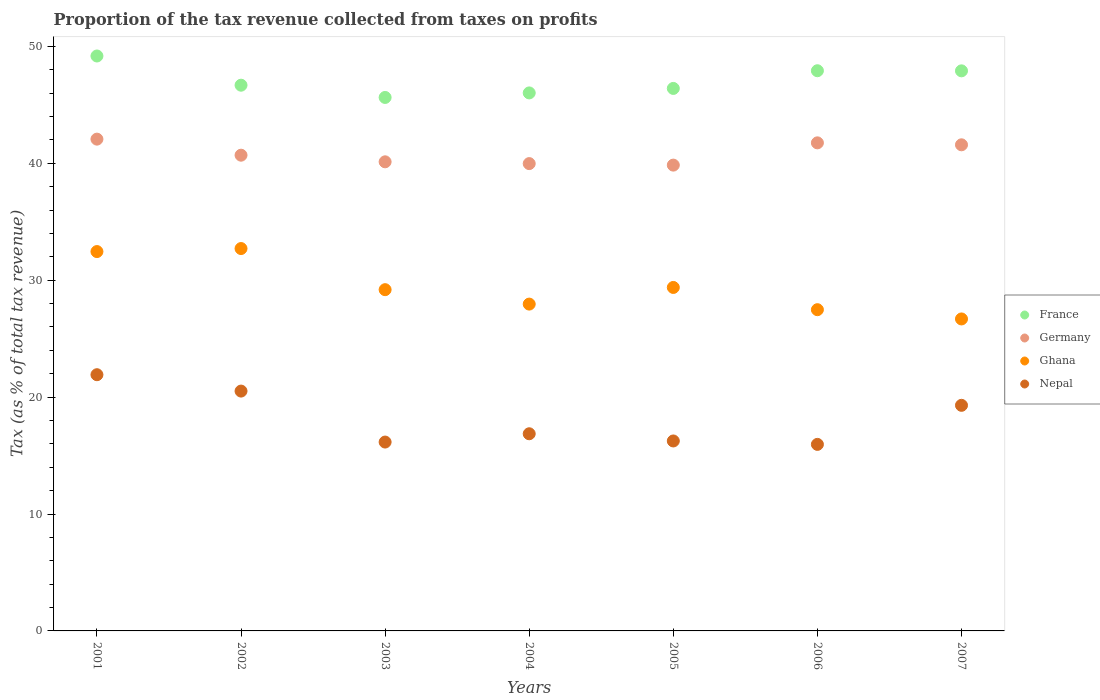What is the proportion of the tax revenue collected in Germany in 2002?
Your response must be concise. 40.69. Across all years, what is the maximum proportion of the tax revenue collected in Ghana?
Provide a succinct answer. 32.7. Across all years, what is the minimum proportion of the tax revenue collected in France?
Make the answer very short. 45.63. In which year was the proportion of the tax revenue collected in Germany minimum?
Provide a succinct answer. 2005. What is the total proportion of the tax revenue collected in Ghana in the graph?
Your answer should be very brief. 205.83. What is the difference between the proportion of the tax revenue collected in France in 2002 and that in 2007?
Your answer should be very brief. -1.23. What is the difference between the proportion of the tax revenue collected in Nepal in 2004 and the proportion of the tax revenue collected in France in 2002?
Give a very brief answer. -29.81. What is the average proportion of the tax revenue collected in Nepal per year?
Provide a short and direct response. 18.13. In the year 2002, what is the difference between the proportion of the tax revenue collected in Germany and proportion of the tax revenue collected in Ghana?
Provide a short and direct response. 7.99. What is the ratio of the proportion of the tax revenue collected in Germany in 2001 to that in 2002?
Make the answer very short. 1.03. Is the proportion of the tax revenue collected in France in 2002 less than that in 2006?
Make the answer very short. Yes. What is the difference between the highest and the second highest proportion of the tax revenue collected in Germany?
Provide a succinct answer. 0.32. What is the difference between the highest and the lowest proportion of the tax revenue collected in Nepal?
Provide a succinct answer. 5.96. In how many years, is the proportion of the tax revenue collected in Nepal greater than the average proportion of the tax revenue collected in Nepal taken over all years?
Provide a short and direct response. 3. Is the sum of the proportion of the tax revenue collected in Germany in 2003 and 2004 greater than the maximum proportion of the tax revenue collected in Ghana across all years?
Provide a succinct answer. Yes. Is it the case that in every year, the sum of the proportion of the tax revenue collected in France and proportion of the tax revenue collected in Nepal  is greater than the sum of proportion of the tax revenue collected in Germany and proportion of the tax revenue collected in Ghana?
Your answer should be very brief. Yes. How many dotlines are there?
Provide a succinct answer. 4. What is the difference between two consecutive major ticks on the Y-axis?
Your answer should be very brief. 10. Are the values on the major ticks of Y-axis written in scientific E-notation?
Make the answer very short. No. Does the graph contain grids?
Your response must be concise. No. How many legend labels are there?
Keep it short and to the point. 4. How are the legend labels stacked?
Provide a short and direct response. Vertical. What is the title of the graph?
Offer a very short reply. Proportion of the tax revenue collected from taxes on profits. Does "Indonesia" appear as one of the legend labels in the graph?
Your answer should be compact. No. What is the label or title of the X-axis?
Provide a short and direct response. Years. What is the label or title of the Y-axis?
Your answer should be compact. Tax (as % of total tax revenue). What is the Tax (as % of total tax revenue) in France in 2001?
Offer a very short reply. 49.17. What is the Tax (as % of total tax revenue) in Germany in 2001?
Offer a very short reply. 42.06. What is the Tax (as % of total tax revenue) in Ghana in 2001?
Provide a succinct answer. 32.45. What is the Tax (as % of total tax revenue) of Nepal in 2001?
Give a very brief answer. 21.91. What is the Tax (as % of total tax revenue) of France in 2002?
Keep it short and to the point. 46.68. What is the Tax (as % of total tax revenue) in Germany in 2002?
Offer a terse response. 40.69. What is the Tax (as % of total tax revenue) of Ghana in 2002?
Offer a terse response. 32.7. What is the Tax (as % of total tax revenue) in Nepal in 2002?
Ensure brevity in your answer.  20.51. What is the Tax (as % of total tax revenue) of France in 2003?
Your response must be concise. 45.63. What is the Tax (as % of total tax revenue) in Germany in 2003?
Ensure brevity in your answer.  40.12. What is the Tax (as % of total tax revenue) in Ghana in 2003?
Ensure brevity in your answer.  29.19. What is the Tax (as % of total tax revenue) in Nepal in 2003?
Keep it short and to the point. 16.15. What is the Tax (as % of total tax revenue) in France in 2004?
Offer a terse response. 46.02. What is the Tax (as % of total tax revenue) in Germany in 2004?
Keep it short and to the point. 39.97. What is the Tax (as % of total tax revenue) of Ghana in 2004?
Provide a succinct answer. 27.95. What is the Tax (as % of total tax revenue) of Nepal in 2004?
Provide a succinct answer. 16.86. What is the Tax (as % of total tax revenue) of France in 2005?
Make the answer very short. 46.4. What is the Tax (as % of total tax revenue) in Germany in 2005?
Offer a terse response. 39.84. What is the Tax (as % of total tax revenue) of Ghana in 2005?
Your answer should be compact. 29.38. What is the Tax (as % of total tax revenue) of Nepal in 2005?
Provide a short and direct response. 16.25. What is the Tax (as % of total tax revenue) of France in 2006?
Your response must be concise. 47.91. What is the Tax (as % of total tax revenue) of Germany in 2006?
Give a very brief answer. 41.74. What is the Tax (as % of total tax revenue) of Ghana in 2006?
Your answer should be very brief. 27.47. What is the Tax (as % of total tax revenue) of Nepal in 2006?
Make the answer very short. 15.95. What is the Tax (as % of total tax revenue) of France in 2007?
Give a very brief answer. 47.9. What is the Tax (as % of total tax revenue) in Germany in 2007?
Your answer should be compact. 41.58. What is the Tax (as % of total tax revenue) in Ghana in 2007?
Offer a very short reply. 26.68. What is the Tax (as % of total tax revenue) of Nepal in 2007?
Give a very brief answer. 19.3. Across all years, what is the maximum Tax (as % of total tax revenue) of France?
Offer a very short reply. 49.17. Across all years, what is the maximum Tax (as % of total tax revenue) of Germany?
Offer a terse response. 42.06. Across all years, what is the maximum Tax (as % of total tax revenue) of Ghana?
Provide a succinct answer. 32.7. Across all years, what is the maximum Tax (as % of total tax revenue) in Nepal?
Offer a very short reply. 21.91. Across all years, what is the minimum Tax (as % of total tax revenue) in France?
Offer a very short reply. 45.63. Across all years, what is the minimum Tax (as % of total tax revenue) of Germany?
Offer a very short reply. 39.84. Across all years, what is the minimum Tax (as % of total tax revenue) in Ghana?
Give a very brief answer. 26.68. Across all years, what is the minimum Tax (as % of total tax revenue) of Nepal?
Your answer should be very brief. 15.95. What is the total Tax (as % of total tax revenue) in France in the graph?
Provide a short and direct response. 329.71. What is the total Tax (as % of total tax revenue) of Germany in the graph?
Make the answer very short. 286.01. What is the total Tax (as % of total tax revenue) of Ghana in the graph?
Keep it short and to the point. 205.83. What is the total Tax (as % of total tax revenue) of Nepal in the graph?
Offer a very short reply. 126.94. What is the difference between the Tax (as % of total tax revenue) of France in 2001 and that in 2002?
Provide a short and direct response. 2.5. What is the difference between the Tax (as % of total tax revenue) of Germany in 2001 and that in 2002?
Ensure brevity in your answer.  1.37. What is the difference between the Tax (as % of total tax revenue) in Ghana in 2001 and that in 2002?
Keep it short and to the point. -0.26. What is the difference between the Tax (as % of total tax revenue) in Nepal in 2001 and that in 2002?
Offer a terse response. 1.4. What is the difference between the Tax (as % of total tax revenue) in France in 2001 and that in 2003?
Keep it short and to the point. 3.55. What is the difference between the Tax (as % of total tax revenue) of Germany in 2001 and that in 2003?
Your answer should be very brief. 1.94. What is the difference between the Tax (as % of total tax revenue) in Ghana in 2001 and that in 2003?
Provide a succinct answer. 3.26. What is the difference between the Tax (as % of total tax revenue) of Nepal in 2001 and that in 2003?
Offer a terse response. 5.76. What is the difference between the Tax (as % of total tax revenue) in France in 2001 and that in 2004?
Keep it short and to the point. 3.16. What is the difference between the Tax (as % of total tax revenue) of Germany in 2001 and that in 2004?
Your response must be concise. 2.09. What is the difference between the Tax (as % of total tax revenue) of Ghana in 2001 and that in 2004?
Keep it short and to the point. 4.49. What is the difference between the Tax (as % of total tax revenue) of Nepal in 2001 and that in 2004?
Give a very brief answer. 5.05. What is the difference between the Tax (as % of total tax revenue) of France in 2001 and that in 2005?
Provide a short and direct response. 2.77. What is the difference between the Tax (as % of total tax revenue) in Germany in 2001 and that in 2005?
Offer a terse response. 2.22. What is the difference between the Tax (as % of total tax revenue) of Ghana in 2001 and that in 2005?
Provide a short and direct response. 3.07. What is the difference between the Tax (as % of total tax revenue) in Nepal in 2001 and that in 2005?
Make the answer very short. 5.67. What is the difference between the Tax (as % of total tax revenue) in France in 2001 and that in 2006?
Make the answer very short. 1.26. What is the difference between the Tax (as % of total tax revenue) in Germany in 2001 and that in 2006?
Make the answer very short. 0.32. What is the difference between the Tax (as % of total tax revenue) in Ghana in 2001 and that in 2006?
Offer a terse response. 4.97. What is the difference between the Tax (as % of total tax revenue) in Nepal in 2001 and that in 2006?
Give a very brief answer. 5.96. What is the difference between the Tax (as % of total tax revenue) of France in 2001 and that in 2007?
Your answer should be compact. 1.27. What is the difference between the Tax (as % of total tax revenue) of Germany in 2001 and that in 2007?
Provide a succinct answer. 0.49. What is the difference between the Tax (as % of total tax revenue) of Ghana in 2001 and that in 2007?
Ensure brevity in your answer.  5.76. What is the difference between the Tax (as % of total tax revenue) in Nepal in 2001 and that in 2007?
Provide a succinct answer. 2.62. What is the difference between the Tax (as % of total tax revenue) in France in 2002 and that in 2003?
Provide a short and direct response. 1.05. What is the difference between the Tax (as % of total tax revenue) of Germany in 2002 and that in 2003?
Make the answer very short. 0.57. What is the difference between the Tax (as % of total tax revenue) in Ghana in 2002 and that in 2003?
Provide a succinct answer. 3.52. What is the difference between the Tax (as % of total tax revenue) of Nepal in 2002 and that in 2003?
Your answer should be very brief. 4.36. What is the difference between the Tax (as % of total tax revenue) of France in 2002 and that in 2004?
Offer a very short reply. 0.66. What is the difference between the Tax (as % of total tax revenue) in Germany in 2002 and that in 2004?
Provide a short and direct response. 0.72. What is the difference between the Tax (as % of total tax revenue) in Ghana in 2002 and that in 2004?
Keep it short and to the point. 4.75. What is the difference between the Tax (as % of total tax revenue) of Nepal in 2002 and that in 2004?
Offer a terse response. 3.65. What is the difference between the Tax (as % of total tax revenue) in France in 2002 and that in 2005?
Provide a short and direct response. 0.28. What is the difference between the Tax (as % of total tax revenue) in Germany in 2002 and that in 2005?
Give a very brief answer. 0.85. What is the difference between the Tax (as % of total tax revenue) of Ghana in 2002 and that in 2005?
Provide a succinct answer. 3.33. What is the difference between the Tax (as % of total tax revenue) in Nepal in 2002 and that in 2005?
Keep it short and to the point. 4.27. What is the difference between the Tax (as % of total tax revenue) in France in 2002 and that in 2006?
Provide a short and direct response. -1.24. What is the difference between the Tax (as % of total tax revenue) in Germany in 2002 and that in 2006?
Offer a very short reply. -1.06. What is the difference between the Tax (as % of total tax revenue) of Ghana in 2002 and that in 2006?
Offer a terse response. 5.23. What is the difference between the Tax (as % of total tax revenue) of Nepal in 2002 and that in 2006?
Give a very brief answer. 4.56. What is the difference between the Tax (as % of total tax revenue) in France in 2002 and that in 2007?
Keep it short and to the point. -1.23. What is the difference between the Tax (as % of total tax revenue) in Germany in 2002 and that in 2007?
Your answer should be very brief. -0.89. What is the difference between the Tax (as % of total tax revenue) in Ghana in 2002 and that in 2007?
Your answer should be compact. 6.02. What is the difference between the Tax (as % of total tax revenue) of Nepal in 2002 and that in 2007?
Provide a short and direct response. 1.22. What is the difference between the Tax (as % of total tax revenue) of France in 2003 and that in 2004?
Give a very brief answer. -0.39. What is the difference between the Tax (as % of total tax revenue) of Germany in 2003 and that in 2004?
Offer a very short reply. 0.15. What is the difference between the Tax (as % of total tax revenue) in Ghana in 2003 and that in 2004?
Your answer should be very brief. 1.23. What is the difference between the Tax (as % of total tax revenue) in Nepal in 2003 and that in 2004?
Give a very brief answer. -0.71. What is the difference between the Tax (as % of total tax revenue) in France in 2003 and that in 2005?
Offer a very short reply. -0.77. What is the difference between the Tax (as % of total tax revenue) of Germany in 2003 and that in 2005?
Ensure brevity in your answer.  0.28. What is the difference between the Tax (as % of total tax revenue) of Ghana in 2003 and that in 2005?
Keep it short and to the point. -0.19. What is the difference between the Tax (as % of total tax revenue) of Nepal in 2003 and that in 2005?
Ensure brevity in your answer.  -0.09. What is the difference between the Tax (as % of total tax revenue) of France in 2003 and that in 2006?
Your response must be concise. -2.29. What is the difference between the Tax (as % of total tax revenue) of Germany in 2003 and that in 2006?
Your answer should be compact. -1.62. What is the difference between the Tax (as % of total tax revenue) of Ghana in 2003 and that in 2006?
Your response must be concise. 1.71. What is the difference between the Tax (as % of total tax revenue) of Nepal in 2003 and that in 2006?
Provide a short and direct response. 0.2. What is the difference between the Tax (as % of total tax revenue) of France in 2003 and that in 2007?
Your answer should be compact. -2.28. What is the difference between the Tax (as % of total tax revenue) in Germany in 2003 and that in 2007?
Your answer should be very brief. -1.45. What is the difference between the Tax (as % of total tax revenue) of Ghana in 2003 and that in 2007?
Ensure brevity in your answer.  2.5. What is the difference between the Tax (as % of total tax revenue) of Nepal in 2003 and that in 2007?
Your answer should be compact. -3.14. What is the difference between the Tax (as % of total tax revenue) in France in 2004 and that in 2005?
Ensure brevity in your answer.  -0.38. What is the difference between the Tax (as % of total tax revenue) of Germany in 2004 and that in 2005?
Provide a short and direct response. 0.13. What is the difference between the Tax (as % of total tax revenue) of Ghana in 2004 and that in 2005?
Make the answer very short. -1.42. What is the difference between the Tax (as % of total tax revenue) in Nepal in 2004 and that in 2005?
Your answer should be compact. 0.62. What is the difference between the Tax (as % of total tax revenue) in France in 2004 and that in 2006?
Make the answer very short. -1.9. What is the difference between the Tax (as % of total tax revenue) of Germany in 2004 and that in 2006?
Provide a succinct answer. -1.77. What is the difference between the Tax (as % of total tax revenue) of Ghana in 2004 and that in 2006?
Provide a succinct answer. 0.48. What is the difference between the Tax (as % of total tax revenue) in Nepal in 2004 and that in 2006?
Provide a short and direct response. 0.91. What is the difference between the Tax (as % of total tax revenue) of France in 2004 and that in 2007?
Give a very brief answer. -1.89. What is the difference between the Tax (as % of total tax revenue) of Germany in 2004 and that in 2007?
Your answer should be very brief. -1.61. What is the difference between the Tax (as % of total tax revenue) of Ghana in 2004 and that in 2007?
Offer a terse response. 1.27. What is the difference between the Tax (as % of total tax revenue) of Nepal in 2004 and that in 2007?
Your answer should be compact. -2.43. What is the difference between the Tax (as % of total tax revenue) in France in 2005 and that in 2006?
Your response must be concise. -1.51. What is the difference between the Tax (as % of total tax revenue) of Germany in 2005 and that in 2006?
Offer a terse response. -1.9. What is the difference between the Tax (as % of total tax revenue) in Ghana in 2005 and that in 2006?
Offer a very short reply. 1.9. What is the difference between the Tax (as % of total tax revenue) in Nepal in 2005 and that in 2006?
Offer a terse response. 0.29. What is the difference between the Tax (as % of total tax revenue) in France in 2005 and that in 2007?
Your answer should be compact. -1.5. What is the difference between the Tax (as % of total tax revenue) of Germany in 2005 and that in 2007?
Offer a very short reply. -1.74. What is the difference between the Tax (as % of total tax revenue) in Ghana in 2005 and that in 2007?
Provide a short and direct response. 2.69. What is the difference between the Tax (as % of total tax revenue) in Nepal in 2005 and that in 2007?
Give a very brief answer. -3.05. What is the difference between the Tax (as % of total tax revenue) in France in 2006 and that in 2007?
Make the answer very short. 0.01. What is the difference between the Tax (as % of total tax revenue) in Germany in 2006 and that in 2007?
Give a very brief answer. 0.17. What is the difference between the Tax (as % of total tax revenue) of Ghana in 2006 and that in 2007?
Give a very brief answer. 0.79. What is the difference between the Tax (as % of total tax revenue) of Nepal in 2006 and that in 2007?
Your response must be concise. -3.34. What is the difference between the Tax (as % of total tax revenue) in France in 2001 and the Tax (as % of total tax revenue) in Germany in 2002?
Your answer should be very brief. 8.48. What is the difference between the Tax (as % of total tax revenue) of France in 2001 and the Tax (as % of total tax revenue) of Ghana in 2002?
Offer a very short reply. 16.47. What is the difference between the Tax (as % of total tax revenue) of France in 2001 and the Tax (as % of total tax revenue) of Nepal in 2002?
Your answer should be compact. 28.66. What is the difference between the Tax (as % of total tax revenue) in Germany in 2001 and the Tax (as % of total tax revenue) in Ghana in 2002?
Make the answer very short. 9.36. What is the difference between the Tax (as % of total tax revenue) in Germany in 2001 and the Tax (as % of total tax revenue) in Nepal in 2002?
Provide a succinct answer. 21.55. What is the difference between the Tax (as % of total tax revenue) of Ghana in 2001 and the Tax (as % of total tax revenue) of Nepal in 2002?
Provide a short and direct response. 11.93. What is the difference between the Tax (as % of total tax revenue) of France in 2001 and the Tax (as % of total tax revenue) of Germany in 2003?
Keep it short and to the point. 9.05. What is the difference between the Tax (as % of total tax revenue) of France in 2001 and the Tax (as % of total tax revenue) of Ghana in 2003?
Make the answer very short. 19.99. What is the difference between the Tax (as % of total tax revenue) in France in 2001 and the Tax (as % of total tax revenue) in Nepal in 2003?
Give a very brief answer. 33.02. What is the difference between the Tax (as % of total tax revenue) of Germany in 2001 and the Tax (as % of total tax revenue) of Ghana in 2003?
Provide a short and direct response. 12.88. What is the difference between the Tax (as % of total tax revenue) of Germany in 2001 and the Tax (as % of total tax revenue) of Nepal in 2003?
Your answer should be compact. 25.91. What is the difference between the Tax (as % of total tax revenue) of Ghana in 2001 and the Tax (as % of total tax revenue) of Nepal in 2003?
Your answer should be compact. 16.29. What is the difference between the Tax (as % of total tax revenue) in France in 2001 and the Tax (as % of total tax revenue) in Germany in 2004?
Keep it short and to the point. 9.2. What is the difference between the Tax (as % of total tax revenue) of France in 2001 and the Tax (as % of total tax revenue) of Ghana in 2004?
Offer a very short reply. 21.22. What is the difference between the Tax (as % of total tax revenue) of France in 2001 and the Tax (as % of total tax revenue) of Nepal in 2004?
Your answer should be compact. 32.31. What is the difference between the Tax (as % of total tax revenue) of Germany in 2001 and the Tax (as % of total tax revenue) of Ghana in 2004?
Your answer should be very brief. 14.11. What is the difference between the Tax (as % of total tax revenue) of Germany in 2001 and the Tax (as % of total tax revenue) of Nepal in 2004?
Your answer should be compact. 25.2. What is the difference between the Tax (as % of total tax revenue) of Ghana in 2001 and the Tax (as % of total tax revenue) of Nepal in 2004?
Offer a terse response. 15.58. What is the difference between the Tax (as % of total tax revenue) of France in 2001 and the Tax (as % of total tax revenue) of Germany in 2005?
Make the answer very short. 9.33. What is the difference between the Tax (as % of total tax revenue) in France in 2001 and the Tax (as % of total tax revenue) in Ghana in 2005?
Ensure brevity in your answer.  19.8. What is the difference between the Tax (as % of total tax revenue) of France in 2001 and the Tax (as % of total tax revenue) of Nepal in 2005?
Provide a short and direct response. 32.93. What is the difference between the Tax (as % of total tax revenue) in Germany in 2001 and the Tax (as % of total tax revenue) in Ghana in 2005?
Offer a terse response. 12.69. What is the difference between the Tax (as % of total tax revenue) in Germany in 2001 and the Tax (as % of total tax revenue) in Nepal in 2005?
Ensure brevity in your answer.  25.82. What is the difference between the Tax (as % of total tax revenue) of Ghana in 2001 and the Tax (as % of total tax revenue) of Nepal in 2005?
Provide a short and direct response. 16.2. What is the difference between the Tax (as % of total tax revenue) in France in 2001 and the Tax (as % of total tax revenue) in Germany in 2006?
Offer a very short reply. 7.43. What is the difference between the Tax (as % of total tax revenue) in France in 2001 and the Tax (as % of total tax revenue) in Ghana in 2006?
Provide a succinct answer. 21.7. What is the difference between the Tax (as % of total tax revenue) in France in 2001 and the Tax (as % of total tax revenue) in Nepal in 2006?
Offer a very short reply. 33.22. What is the difference between the Tax (as % of total tax revenue) in Germany in 2001 and the Tax (as % of total tax revenue) in Ghana in 2006?
Your response must be concise. 14.59. What is the difference between the Tax (as % of total tax revenue) in Germany in 2001 and the Tax (as % of total tax revenue) in Nepal in 2006?
Provide a succinct answer. 26.11. What is the difference between the Tax (as % of total tax revenue) of Ghana in 2001 and the Tax (as % of total tax revenue) of Nepal in 2006?
Give a very brief answer. 16.49. What is the difference between the Tax (as % of total tax revenue) of France in 2001 and the Tax (as % of total tax revenue) of Germany in 2007?
Your response must be concise. 7.6. What is the difference between the Tax (as % of total tax revenue) in France in 2001 and the Tax (as % of total tax revenue) in Ghana in 2007?
Make the answer very short. 22.49. What is the difference between the Tax (as % of total tax revenue) of France in 2001 and the Tax (as % of total tax revenue) of Nepal in 2007?
Ensure brevity in your answer.  29.88. What is the difference between the Tax (as % of total tax revenue) of Germany in 2001 and the Tax (as % of total tax revenue) of Ghana in 2007?
Your answer should be compact. 15.38. What is the difference between the Tax (as % of total tax revenue) of Germany in 2001 and the Tax (as % of total tax revenue) of Nepal in 2007?
Ensure brevity in your answer.  22.77. What is the difference between the Tax (as % of total tax revenue) of Ghana in 2001 and the Tax (as % of total tax revenue) of Nepal in 2007?
Keep it short and to the point. 13.15. What is the difference between the Tax (as % of total tax revenue) in France in 2002 and the Tax (as % of total tax revenue) in Germany in 2003?
Keep it short and to the point. 6.55. What is the difference between the Tax (as % of total tax revenue) of France in 2002 and the Tax (as % of total tax revenue) of Ghana in 2003?
Your answer should be very brief. 17.49. What is the difference between the Tax (as % of total tax revenue) in France in 2002 and the Tax (as % of total tax revenue) in Nepal in 2003?
Give a very brief answer. 30.52. What is the difference between the Tax (as % of total tax revenue) of Germany in 2002 and the Tax (as % of total tax revenue) of Ghana in 2003?
Provide a succinct answer. 11.5. What is the difference between the Tax (as % of total tax revenue) in Germany in 2002 and the Tax (as % of total tax revenue) in Nepal in 2003?
Give a very brief answer. 24.54. What is the difference between the Tax (as % of total tax revenue) in Ghana in 2002 and the Tax (as % of total tax revenue) in Nepal in 2003?
Your answer should be compact. 16.55. What is the difference between the Tax (as % of total tax revenue) in France in 2002 and the Tax (as % of total tax revenue) in Germany in 2004?
Ensure brevity in your answer.  6.71. What is the difference between the Tax (as % of total tax revenue) of France in 2002 and the Tax (as % of total tax revenue) of Ghana in 2004?
Your response must be concise. 18.72. What is the difference between the Tax (as % of total tax revenue) in France in 2002 and the Tax (as % of total tax revenue) in Nepal in 2004?
Your response must be concise. 29.81. What is the difference between the Tax (as % of total tax revenue) of Germany in 2002 and the Tax (as % of total tax revenue) of Ghana in 2004?
Give a very brief answer. 12.74. What is the difference between the Tax (as % of total tax revenue) of Germany in 2002 and the Tax (as % of total tax revenue) of Nepal in 2004?
Provide a short and direct response. 23.83. What is the difference between the Tax (as % of total tax revenue) in Ghana in 2002 and the Tax (as % of total tax revenue) in Nepal in 2004?
Make the answer very short. 15.84. What is the difference between the Tax (as % of total tax revenue) in France in 2002 and the Tax (as % of total tax revenue) in Germany in 2005?
Provide a short and direct response. 6.84. What is the difference between the Tax (as % of total tax revenue) of France in 2002 and the Tax (as % of total tax revenue) of Ghana in 2005?
Ensure brevity in your answer.  17.3. What is the difference between the Tax (as % of total tax revenue) of France in 2002 and the Tax (as % of total tax revenue) of Nepal in 2005?
Your answer should be compact. 30.43. What is the difference between the Tax (as % of total tax revenue) in Germany in 2002 and the Tax (as % of total tax revenue) in Ghana in 2005?
Give a very brief answer. 11.31. What is the difference between the Tax (as % of total tax revenue) of Germany in 2002 and the Tax (as % of total tax revenue) of Nepal in 2005?
Make the answer very short. 24.44. What is the difference between the Tax (as % of total tax revenue) in Ghana in 2002 and the Tax (as % of total tax revenue) in Nepal in 2005?
Give a very brief answer. 16.46. What is the difference between the Tax (as % of total tax revenue) of France in 2002 and the Tax (as % of total tax revenue) of Germany in 2006?
Your answer should be compact. 4.93. What is the difference between the Tax (as % of total tax revenue) of France in 2002 and the Tax (as % of total tax revenue) of Ghana in 2006?
Give a very brief answer. 19.2. What is the difference between the Tax (as % of total tax revenue) in France in 2002 and the Tax (as % of total tax revenue) in Nepal in 2006?
Your response must be concise. 30.72. What is the difference between the Tax (as % of total tax revenue) in Germany in 2002 and the Tax (as % of total tax revenue) in Ghana in 2006?
Make the answer very short. 13.21. What is the difference between the Tax (as % of total tax revenue) in Germany in 2002 and the Tax (as % of total tax revenue) in Nepal in 2006?
Ensure brevity in your answer.  24.73. What is the difference between the Tax (as % of total tax revenue) of Ghana in 2002 and the Tax (as % of total tax revenue) of Nepal in 2006?
Your answer should be compact. 16.75. What is the difference between the Tax (as % of total tax revenue) in France in 2002 and the Tax (as % of total tax revenue) in Germany in 2007?
Keep it short and to the point. 5.1. What is the difference between the Tax (as % of total tax revenue) in France in 2002 and the Tax (as % of total tax revenue) in Ghana in 2007?
Make the answer very short. 19.99. What is the difference between the Tax (as % of total tax revenue) in France in 2002 and the Tax (as % of total tax revenue) in Nepal in 2007?
Your answer should be compact. 27.38. What is the difference between the Tax (as % of total tax revenue) in Germany in 2002 and the Tax (as % of total tax revenue) in Ghana in 2007?
Your answer should be very brief. 14.01. What is the difference between the Tax (as % of total tax revenue) of Germany in 2002 and the Tax (as % of total tax revenue) of Nepal in 2007?
Keep it short and to the point. 21.39. What is the difference between the Tax (as % of total tax revenue) of Ghana in 2002 and the Tax (as % of total tax revenue) of Nepal in 2007?
Keep it short and to the point. 13.41. What is the difference between the Tax (as % of total tax revenue) in France in 2003 and the Tax (as % of total tax revenue) in Germany in 2004?
Make the answer very short. 5.66. What is the difference between the Tax (as % of total tax revenue) of France in 2003 and the Tax (as % of total tax revenue) of Ghana in 2004?
Make the answer very short. 17.67. What is the difference between the Tax (as % of total tax revenue) in France in 2003 and the Tax (as % of total tax revenue) in Nepal in 2004?
Ensure brevity in your answer.  28.76. What is the difference between the Tax (as % of total tax revenue) of Germany in 2003 and the Tax (as % of total tax revenue) of Ghana in 2004?
Keep it short and to the point. 12.17. What is the difference between the Tax (as % of total tax revenue) in Germany in 2003 and the Tax (as % of total tax revenue) in Nepal in 2004?
Your answer should be compact. 23.26. What is the difference between the Tax (as % of total tax revenue) in Ghana in 2003 and the Tax (as % of total tax revenue) in Nepal in 2004?
Give a very brief answer. 12.32. What is the difference between the Tax (as % of total tax revenue) of France in 2003 and the Tax (as % of total tax revenue) of Germany in 2005?
Your answer should be compact. 5.79. What is the difference between the Tax (as % of total tax revenue) of France in 2003 and the Tax (as % of total tax revenue) of Ghana in 2005?
Provide a short and direct response. 16.25. What is the difference between the Tax (as % of total tax revenue) in France in 2003 and the Tax (as % of total tax revenue) in Nepal in 2005?
Offer a very short reply. 29.38. What is the difference between the Tax (as % of total tax revenue) of Germany in 2003 and the Tax (as % of total tax revenue) of Ghana in 2005?
Provide a succinct answer. 10.75. What is the difference between the Tax (as % of total tax revenue) in Germany in 2003 and the Tax (as % of total tax revenue) in Nepal in 2005?
Offer a terse response. 23.88. What is the difference between the Tax (as % of total tax revenue) of Ghana in 2003 and the Tax (as % of total tax revenue) of Nepal in 2005?
Ensure brevity in your answer.  12.94. What is the difference between the Tax (as % of total tax revenue) in France in 2003 and the Tax (as % of total tax revenue) in Germany in 2006?
Make the answer very short. 3.88. What is the difference between the Tax (as % of total tax revenue) in France in 2003 and the Tax (as % of total tax revenue) in Ghana in 2006?
Provide a succinct answer. 18.15. What is the difference between the Tax (as % of total tax revenue) of France in 2003 and the Tax (as % of total tax revenue) of Nepal in 2006?
Your answer should be very brief. 29.67. What is the difference between the Tax (as % of total tax revenue) of Germany in 2003 and the Tax (as % of total tax revenue) of Ghana in 2006?
Your answer should be very brief. 12.65. What is the difference between the Tax (as % of total tax revenue) of Germany in 2003 and the Tax (as % of total tax revenue) of Nepal in 2006?
Your answer should be compact. 24.17. What is the difference between the Tax (as % of total tax revenue) in Ghana in 2003 and the Tax (as % of total tax revenue) in Nepal in 2006?
Your answer should be very brief. 13.23. What is the difference between the Tax (as % of total tax revenue) in France in 2003 and the Tax (as % of total tax revenue) in Germany in 2007?
Offer a very short reply. 4.05. What is the difference between the Tax (as % of total tax revenue) in France in 2003 and the Tax (as % of total tax revenue) in Ghana in 2007?
Offer a terse response. 18.94. What is the difference between the Tax (as % of total tax revenue) in France in 2003 and the Tax (as % of total tax revenue) in Nepal in 2007?
Provide a short and direct response. 26.33. What is the difference between the Tax (as % of total tax revenue) of Germany in 2003 and the Tax (as % of total tax revenue) of Ghana in 2007?
Offer a terse response. 13.44. What is the difference between the Tax (as % of total tax revenue) in Germany in 2003 and the Tax (as % of total tax revenue) in Nepal in 2007?
Ensure brevity in your answer.  20.83. What is the difference between the Tax (as % of total tax revenue) in Ghana in 2003 and the Tax (as % of total tax revenue) in Nepal in 2007?
Provide a succinct answer. 9.89. What is the difference between the Tax (as % of total tax revenue) in France in 2004 and the Tax (as % of total tax revenue) in Germany in 2005?
Your response must be concise. 6.18. What is the difference between the Tax (as % of total tax revenue) in France in 2004 and the Tax (as % of total tax revenue) in Ghana in 2005?
Keep it short and to the point. 16.64. What is the difference between the Tax (as % of total tax revenue) in France in 2004 and the Tax (as % of total tax revenue) in Nepal in 2005?
Offer a very short reply. 29.77. What is the difference between the Tax (as % of total tax revenue) of Germany in 2004 and the Tax (as % of total tax revenue) of Ghana in 2005?
Give a very brief answer. 10.59. What is the difference between the Tax (as % of total tax revenue) of Germany in 2004 and the Tax (as % of total tax revenue) of Nepal in 2005?
Ensure brevity in your answer.  23.72. What is the difference between the Tax (as % of total tax revenue) in Ghana in 2004 and the Tax (as % of total tax revenue) in Nepal in 2005?
Give a very brief answer. 11.71. What is the difference between the Tax (as % of total tax revenue) of France in 2004 and the Tax (as % of total tax revenue) of Germany in 2006?
Provide a succinct answer. 4.27. What is the difference between the Tax (as % of total tax revenue) in France in 2004 and the Tax (as % of total tax revenue) in Ghana in 2006?
Your answer should be very brief. 18.54. What is the difference between the Tax (as % of total tax revenue) in France in 2004 and the Tax (as % of total tax revenue) in Nepal in 2006?
Offer a very short reply. 30.06. What is the difference between the Tax (as % of total tax revenue) in Germany in 2004 and the Tax (as % of total tax revenue) in Ghana in 2006?
Provide a succinct answer. 12.5. What is the difference between the Tax (as % of total tax revenue) in Germany in 2004 and the Tax (as % of total tax revenue) in Nepal in 2006?
Your response must be concise. 24.02. What is the difference between the Tax (as % of total tax revenue) of Ghana in 2004 and the Tax (as % of total tax revenue) of Nepal in 2006?
Your answer should be compact. 12. What is the difference between the Tax (as % of total tax revenue) in France in 2004 and the Tax (as % of total tax revenue) in Germany in 2007?
Offer a very short reply. 4.44. What is the difference between the Tax (as % of total tax revenue) of France in 2004 and the Tax (as % of total tax revenue) of Ghana in 2007?
Provide a short and direct response. 19.33. What is the difference between the Tax (as % of total tax revenue) of France in 2004 and the Tax (as % of total tax revenue) of Nepal in 2007?
Keep it short and to the point. 26.72. What is the difference between the Tax (as % of total tax revenue) of Germany in 2004 and the Tax (as % of total tax revenue) of Ghana in 2007?
Your answer should be very brief. 13.29. What is the difference between the Tax (as % of total tax revenue) of Germany in 2004 and the Tax (as % of total tax revenue) of Nepal in 2007?
Your answer should be very brief. 20.67. What is the difference between the Tax (as % of total tax revenue) in Ghana in 2004 and the Tax (as % of total tax revenue) in Nepal in 2007?
Make the answer very short. 8.66. What is the difference between the Tax (as % of total tax revenue) in France in 2005 and the Tax (as % of total tax revenue) in Germany in 2006?
Provide a succinct answer. 4.65. What is the difference between the Tax (as % of total tax revenue) of France in 2005 and the Tax (as % of total tax revenue) of Ghana in 2006?
Offer a terse response. 18.93. What is the difference between the Tax (as % of total tax revenue) in France in 2005 and the Tax (as % of total tax revenue) in Nepal in 2006?
Offer a very short reply. 30.44. What is the difference between the Tax (as % of total tax revenue) of Germany in 2005 and the Tax (as % of total tax revenue) of Ghana in 2006?
Your answer should be very brief. 12.37. What is the difference between the Tax (as % of total tax revenue) of Germany in 2005 and the Tax (as % of total tax revenue) of Nepal in 2006?
Your answer should be compact. 23.89. What is the difference between the Tax (as % of total tax revenue) in Ghana in 2005 and the Tax (as % of total tax revenue) in Nepal in 2006?
Give a very brief answer. 13.42. What is the difference between the Tax (as % of total tax revenue) of France in 2005 and the Tax (as % of total tax revenue) of Germany in 2007?
Ensure brevity in your answer.  4.82. What is the difference between the Tax (as % of total tax revenue) in France in 2005 and the Tax (as % of total tax revenue) in Ghana in 2007?
Your answer should be very brief. 19.72. What is the difference between the Tax (as % of total tax revenue) of France in 2005 and the Tax (as % of total tax revenue) of Nepal in 2007?
Your answer should be very brief. 27.1. What is the difference between the Tax (as % of total tax revenue) of Germany in 2005 and the Tax (as % of total tax revenue) of Ghana in 2007?
Offer a very short reply. 13.16. What is the difference between the Tax (as % of total tax revenue) in Germany in 2005 and the Tax (as % of total tax revenue) in Nepal in 2007?
Your answer should be very brief. 20.55. What is the difference between the Tax (as % of total tax revenue) in Ghana in 2005 and the Tax (as % of total tax revenue) in Nepal in 2007?
Your answer should be compact. 10.08. What is the difference between the Tax (as % of total tax revenue) in France in 2006 and the Tax (as % of total tax revenue) in Germany in 2007?
Offer a very short reply. 6.34. What is the difference between the Tax (as % of total tax revenue) of France in 2006 and the Tax (as % of total tax revenue) of Ghana in 2007?
Offer a very short reply. 21.23. What is the difference between the Tax (as % of total tax revenue) of France in 2006 and the Tax (as % of total tax revenue) of Nepal in 2007?
Your response must be concise. 28.62. What is the difference between the Tax (as % of total tax revenue) in Germany in 2006 and the Tax (as % of total tax revenue) in Ghana in 2007?
Offer a terse response. 15.06. What is the difference between the Tax (as % of total tax revenue) of Germany in 2006 and the Tax (as % of total tax revenue) of Nepal in 2007?
Provide a succinct answer. 22.45. What is the difference between the Tax (as % of total tax revenue) in Ghana in 2006 and the Tax (as % of total tax revenue) in Nepal in 2007?
Make the answer very short. 8.18. What is the average Tax (as % of total tax revenue) of France per year?
Offer a terse response. 47.1. What is the average Tax (as % of total tax revenue) in Germany per year?
Give a very brief answer. 40.86. What is the average Tax (as % of total tax revenue) of Ghana per year?
Ensure brevity in your answer.  29.4. What is the average Tax (as % of total tax revenue) of Nepal per year?
Provide a short and direct response. 18.13. In the year 2001, what is the difference between the Tax (as % of total tax revenue) in France and Tax (as % of total tax revenue) in Germany?
Your response must be concise. 7.11. In the year 2001, what is the difference between the Tax (as % of total tax revenue) in France and Tax (as % of total tax revenue) in Ghana?
Your response must be concise. 16.73. In the year 2001, what is the difference between the Tax (as % of total tax revenue) of France and Tax (as % of total tax revenue) of Nepal?
Your answer should be very brief. 27.26. In the year 2001, what is the difference between the Tax (as % of total tax revenue) in Germany and Tax (as % of total tax revenue) in Ghana?
Ensure brevity in your answer.  9.62. In the year 2001, what is the difference between the Tax (as % of total tax revenue) of Germany and Tax (as % of total tax revenue) of Nepal?
Offer a very short reply. 20.15. In the year 2001, what is the difference between the Tax (as % of total tax revenue) in Ghana and Tax (as % of total tax revenue) in Nepal?
Ensure brevity in your answer.  10.53. In the year 2002, what is the difference between the Tax (as % of total tax revenue) of France and Tax (as % of total tax revenue) of Germany?
Your response must be concise. 5.99. In the year 2002, what is the difference between the Tax (as % of total tax revenue) in France and Tax (as % of total tax revenue) in Ghana?
Ensure brevity in your answer.  13.97. In the year 2002, what is the difference between the Tax (as % of total tax revenue) of France and Tax (as % of total tax revenue) of Nepal?
Your response must be concise. 26.16. In the year 2002, what is the difference between the Tax (as % of total tax revenue) in Germany and Tax (as % of total tax revenue) in Ghana?
Provide a short and direct response. 7.99. In the year 2002, what is the difference between the Tax (as % of total tax revenue) of Germany and Tax (as % of total tax revenue) of Nepal?
Provide a short and direct response. 20.18. In the year 2002, what is the difference between the Tax (as % of total tax revenue) in Ghana and Tax (as % of total tax revenue) in Nepal?
Your answer should be compact. 12.19. In the year 2003, what is the difference between the Tax (as % of total tax revenue) in France and Tax (as % of total tax revenue) in Germany?
Give a very brief answer. 5.5. In the year 2003, what is the difference between the Tax (as % of total tax revenue) of France and Tax (as % of total tax revenue) of Ghana?
Offer a terse response. 16.44. In the year 2003, what is the difference between the Tax (as % of total tax revenue) of France and Tax (as % of total tax revenue) of Nepal?
Keep it short and to the point. 29.47. In the year 2003, what is the difference between the Tax (as % of total tax revenue) in Germany and Tax (as % of total tax revenue) in Ghana?
Keep it short and to the point. 10.94. In the year 2003, what is the difference between the Tax (as % of total tax revenue) of Germany and Tax (as % of total tax revenue) of Nepal?
Your response must be concise. 23.97. In the year 2003, what is the difference between the Tax (as % of total tax revenue) in Ghana and Tax (as % of total tax revenue) in Nepal?
Offer a terse response. 13.03. In the year 2004, what is the difference between the Tax (as % of total tax revenue) of France and Tax (as % of total tax revenue) of Germany?
Your response must be concise. 6.05. In the year 2004, what is the difference between the Tax (as % of total tax revenue) in France and Tax (as % of total tax revenue) in Ghana?
Ensure brevity in your answer.  18.06. In the year 2004, what is the difference between the Tax (as % of total tax revenue) of France and Tax (as % of total tax revenue) of Nepal?
Your response must be concise. 29.15. In the year 2004, what is the difference between the Tax (as % of total tax revenue) in Germany and Tax (as % of total tax revenue) in Ghana?
Offer a very short reply. 12.02. In the year 2004, what is the difference between the Tax (as % of total tax revenue) in Germany and Tax (as % of total tax revenue) in Nepal?
Provide a succinct answer. 23.11. In the year 2004, what is the difference between the Tax (as % of total tax revenue) in Ghana and Tax (as % of total tax revenue) in Nepal?
Keep it short and to the point. 11.09. In the year 2005, what is the difference between the Tax (as % of total tax revenue) in France and Tax (as % of total tax revenue) in Germany?
Offer a terse response. 6.56. In the year 2005, what is the difference between the Tax (as % of total tax revenue) in France and Tax (as % of total tax revenue) in Ghana?
Your answer should be very brief. 17.02. In the year 2005, what is the difference between the Tax (as % of total tax revenue) in France and Tax (as % of total tax revenue) in Nepal?
Keep it short and to the point. 30.15. In the year 2005, what is the difference between the Tax (as % of total tax revenue) in Germany and Tax (as % of total tax revenue) in Ghana?
Give a very brief answer. 10.46. In the year 2005, what is the difference between the Tax (as % of total tax revenue) in Germany and Tax (as % of total tax revenue) in Nepal?
Give a very brief answer. 23.59. In the year 2005, what is the difference between the Tax (as % of total tax revenue) in Ghana and Tax (as % of total tax revenue) in Nepal?
Provide a succinct answer. 13.13. In the year 2006, what is the difference between the Tax (as % of total tax revenue) in France and Tax (as % of total tax revenue) in Germany?
Ensure brevity in your answer.  6.17. In the year 2006, what is the difference between the Tax (as % of total tax revenue) of France and Tax (as % of total tax revenue) of Ghana?
Provide a short and direct response. 20.44. In the year 2006, what is the difference between the Tax (as % of total tax revenue) of France and Tax (as % of total tax revenue) of Nepal?
Offer a terse response. 31.96. In the year 2006, what is the difference between the Tax (as % of total tax revenue) in Germany and Tax (as % of total tax revenue) in Ghana?
Keep it short and to the point. 14.27. In the year 2006, what is the difference between the Tax (as % of total tax revenue) in Germany and Tax (as % of total tax revenue) in Nepal?
Your answer should be compact. 25.79. In the year 2006, what is the difference between the Tax (as % of total tax revenue) of Ghana and Tax (as % of total tax revenue) of Nepal?
Provide a succinct answer. 11.52. In the year 2007, what is the difference between the Tax (as % of total tax revenue) of France and Tax (as % of total tax revenue) of Germany?
Your answer should be compact. 6.33. In the year 2007, what is the difference between the Tax (as % of total tax revenue) of France and Tax (as % of total tax revenue) of Ghana?
Your answer should be very brief. 21.22. In the year 2007, what is the difference between the Tax (as % of total tax revenue) of France and Tax (as % of total tax revenue) of Nepal?
Your answer should be very brief. 28.61. In the year 2007, what is the difference between the Tax (as % of total tax revenue) in Germany and Tax (as % of total tax revenue) in Ghana?
Give a very brief answer. 14.89. In the year 2007, what is the difference between the Tax (as % of total tax revenue) in Germany and Tax (as % of total tax revenue) in Nepal?
Offer a terse response. 22.28. In the year 2007, what is the difference between the Tax (as % of total tax revenue) of Ghana and Tax (as % of total tax revenue) of Nepal?
Ensure brevity in your answer.  7.39. What is the ratio of the Tax (as % of total tax revenue) of France in 2001 to that in 2002?
Provide a succinct answer. 1.05. What is the ratio of the Tax (as % of total tax revenue) in Germany in 2001 to that in 2002?
Make the answer very short. 1.03. What is the ratio of the Tax (as % of total tax revenue) in Ghana in 2001 to that in 2002?
Your response must be concise. 0.99. What is the ratio of the Tax (as % of total tax revenue) in Nepal in 2001 to that in 2002?
Keep it short and to the point. 1.07. What is the ratio of the Tax (as % of total tax revenue) of France in 2001 to that in 2003?
Offer a terse response. 1.08. What is the ratio of the Tax (as % of total tax revenue) of Germany in 2001 to that in 2003?
Your response must be concise. 1.05. What is the ratio of the Tax (as % of total tax revenue) in Ghana in 2001 to that in 2003?
Your answer should be compact. 1.11. What is the ratio of the Tax (as % of total tax revenue) of Nepal in 2001 to that in 2003?
Offer a terse response. 1.36. What is the ratio of the Tax (as % of total tax revenue) in France in 2001 to that in 2004?
Your answer should be compact. 1.07. What is the ratio of the Tax (as % of total tax revenue) in Germany in 2001 to that in 2004?
Make the answer very short. 1.05. What is the ratio of the Tax (as % of total tax revenue) of Ghana in 2001 to that in 2004?
Make the answer very short. 1.16. What is the ratio of the Tax (as % of total tax revenue) in Nepal in 2001 to that in 2004?
Offer a terse response. 1.3. What is the ratio of the Tax (as % of total tax revenue) of France in 2001 to that in 2005?
Keep it short and to the point. 1.06. What is the ratio of the Tax (as % of total tax revenue) of Germany in 2001 to that in 2005?
Provide a short and direct response. 1.06. What is the ratio of the Tax (as % of total tax revenue) in Ghana in 2001 to that in 2005?
Offer a very short reply. 1.1. What is the ratio of the Tax (as % of total tax revenue) of Nepal in 2001 to that in 2005?
Offer a terse response. 1.35. What is the ratio of the Tax (as % of total tax revenue) of France in 2001 to that in 2006?
Offer a terse response. 1.03. What is the ratio of the Tax (as % of total tax revenue) of Germany in 2001 to that in 2006?
Provide a short and direct response. 1.01. What is the ratio of the Tax (as % of total tax revenue) in Ghana in 2001 to that in 2006?
Offer a very short reply. 1.18. What is the ratio of the Tax (as % of total tax revenue) in Nepal in 2001 to that in 2006?
Provide a succinct answer. 1.37. What is the ratio of the Tax (as % of total tax revenue) of France in 2001 to that in 2007?
Make the answer very short. 1.03. What is the ratio of the Tax (as % of total tax revenue) of Germany in 2001 to that in 2007?
Provide a short and direct response. 1.01. What is the ratio of the Tax (as % of total tax revenue) of Ghana in 2001 to that in 2007?
Your answer should be compact. 1.22. What is the ratio of the Tax (as % of total tax revenue) in Nepal in 2001 to that in 2007?
Your answer should be compact. 1.14. What is the ratio of the Tax (as % of total tax revenue) of France in 2002 to that in 2003?
Offer a terse response. 1.02. What is the ratio of the Tax (as % of total tax revenue) of Germany in 2002 to that in 2003?
Provide a succinct answer. 1.01. What is the ratio of the Tax (as % of total tax revenue) of Ghana in 2002 to that in 2003?
Ensure brevity in your answer.  1.12. What is the ratio of the Tax (as % of total tax revenue) in Nepal in 2002 to that in 2003?
Give a very brief answer. 1.27. What is the ratio of the Tax (as % of total tax revenue) of France in 2002 to that in 2004?
Give a very brief answer. 1.01. What is the ratio of the Tax (as % of total tax revenue) in Ghana in 2002 to that in 2004?
Your answer should be very brief. 1.17. What is the ratio of the Tax (as % of total tax revenue) of Nepal in 2002 to that in 2004?
Your answer should be compact. 1.22. What is the ratio of the Tax (as % of total tax revenue) of Germany in 2002 to that in 2005?
Make the answer very short. 1.02. What is the ratio of the Tax (as % of total tax revenue) in Ghana in 2002 to that in 2005?
Provide a short and direct response. 1.11. What is the ratio of the Tax (as % of total tax revenue) in Nepal in 2002 to that in 2005?
Your answer should be very brief. 1.26. What is the ratio of the Tax (as % of total tax revenue) of France in 2002 to that in 2006?
Offer a very short reply. 0.97. What is the ratio of the Tax (as % of total tax revenue) of Germany in 2002 to that in 2006?
Provide a short and direct response. 0.97. What is the ratio of the Tax (as % of total tax revenue) of Ghana in 2002 to that in 2006?
Provide a short and direct response. 1.19. What is the ratio of the Tax (as % of total tax revenue) in France in 2002 to that in 2007?
Ensure brevity in your answer.  0.97. What is the ratio of the Tax (as % of total tax revenue) of Germany in 2002 to that in 2007?
Your answer should be very brief. 0.98. What is the ratio of the Tax (as % of total tax revenue) in Ghana in 2002 to that in 2007?
Ensure brevity in your answer.  1.23. What is the ratio of the Tax (as % of total tax revenue) of Nepal in 2002 to that in 2007?
Offer a terse response. 1.06. What is the ratio of the Tax (as % of total tax revenue) in France in 2003 to that in 2004?
Offer a terse response. 0.99. What is the ratio of the Tax (as % of total tax revenue) of Germany in 2003 to that in 2004?
Make the answer very short. 1. What is the ratio of the Tax (as % of total tax revenue) of Ghana in 2003 to that in 2004?
Provide a short and direct response. 1.04. What is the ratio of the Tax (as % of total tax revenue) in Nepal in 2003 to that in 2004?
Make the answer very short. 0.96. What is the ratio of the Tax (as % of total tax revenue) of France in 2003 to that in 2005?
Provide a succinct answer. 0.98. What is the ratio of the Tax (as % of total tax revenue) in Germany in 2003 to that in 2005?
Your answer should be very brief. 1.01. What is the ratio of the Tax (as % of total tax revenue) in Ghana in 2003 to that in 2005?
Make the answer very short. 0.99. What is the ratio of the Tax (as % of total tax revenue) in Nepal in 2003 to that in 2005?
Give a very brief answer. 0.99. What is the ratio of the Tax (as % of total tax revenue) of France in 2003 to that in 2006?
Ensure brevity in your answer.  0.95. What is the ratio of the Tax (as % of total tax revenue) in Germany in 2003 to that in 2006?
Ensure brevity in your answer.  0.96. What is the ratio of the Tax (as % of total tax revenue) of Ghana in 2003 to that in 2006?
Ensure brevity in your answer.  1.06. What is the ratio of the Tax (as % of total tax revenue) of Nepal in 2003 to that in 2006?
Ensure brevity in your answer.  1.01. What is the ratio of the Tax (as % of total tax revenue) in France in 2003 to that in 2007?
Your response must be concise. 0.95. What is the ratio of the Tax (as % of total tax revenue) of Ghana in 2003 to that in 2007?
Your answer should be compact. 1.09. What is the ratio of the Tax (as % of total tax revenue) in Nepal in 2003 to that in 2007?
Make the answer very short. 0.84. What is the ratio of the Tax (as % of total tax revenue) of Germany in 2004 to that in 2005?
Your answer should be compact. 1. What is the ratio of the Tax (as % of total tax revenue) in Ghana in 2004 to that in 2005?
Provide a succinct answer. 0.95. What is the ratio of the Tax (as % of total tax revenue) of Nepal in 2004 to that in 2005?
Your answer should be very brief. 1.04. What is the ratio of the Tax (as % of total tax revenue) in France in 2004 to that in 2006?
Provide a short and direct response. 0.96. What is the ratio of the Tax (as % of total tax revenue) in Germany in 2004 to that in 2006?
Make the answer very short. 0.96. What is the ratio of the Tax (as % of total tax revenue) of Ghana in 2004 to that in 2006?
Keep it short and to the point. 1.02. What is the ratio of the Tax (as % of total tax revenue) of Nepal in 2004 to that in 2006?
Offer a very short reply. 1.06. What is the ratio of the Tax (as % of total tax revenue) of France in 2004 to that in 2007?
Offer a very short reply. 0.96. What is the ratio of the Tax (as % of total tax revenue) in Germany in 2004 to that in 2007?
Ensure brevity in your answer.  0.96. What is the ratio of the Tax (as % of total tax revenue) in Ghana in 2004 to that in 2007?
Make the answer very short. 1.05. What is the ratio of the Tax (as % of total tax revenue) in Nepal in 2004 to that in 2007?
Offer a very short reply. 0.87. What is the ratio of the Tax (as % of total tax revenue) in France in 2005 to that in 2006?
Offer a terse response. 0.97. What is the ratio of the Tax (as % of total tax revenue) in Germany in 2005 to that in 2006?
Make the answer very short. 0.95. What is the ratio of the Tax (as % of total tax revenue) in Ghana in 2005 to that in 2006?
Provide a short and direct response. 1.07. What is the ratio of the Tax (as % of total tax revenue) of Nepal in 2005 to that in 2006?
Your answer should be compact. 1.02. What is the ratio of the Tax (as % of total tax revenue) of France in 2005 to that in 2007?
Make the answer very short. 0.97. What is the ratio of the Tax (as % of total tax revenue) of Germany in 2005 to that in 2007?
Ensure brevity in your answer.  0.96. What is the ratio of the Tax (as % of total tax revenue) in Ghana in 2005 to that in 2007?
Your response must be concise. 1.1. What is the ratio of the Tax (as % of total tax revenue) in Nepal in 2005 to that in 2007?
Provide a short and direct response. 0.84. What is the ratio of the Tax (as % of total tax revenue) in France in 2006 to that in 2007?
Offer a very short reply. 1. What is the ratio of the Tax (as % of total tax revenue) of Ghana in 2006 to that in 2007?
Make the answer very short. 1.03. What is the ratio of the Tax (as % of total tax revenue) of Nepal in 2006 to that in 2007?
Offer a terse response. 0.83. What is the difference between the highest and the second highest Tax (as % of total tax revenue) in France?
Ensure brevity in your answer.  1.26. What is the difference between the highest and the second highest Tax (as % of total tax revenue) of Germany?
Provide a succinct answer. 0.32. What is the difference between the highest and the second highest Tax (as % of total tax revenue) in Ghana?
Keep it short and to the point. 0.26. What is the difference between the highest and the second highest Tax (as % of total tax revenue) in Nepal?
Provide a short and direct response. 1.4. What is the difference between the highest and the lowest Tax (as % of total tax revenue) of France?
Your response must be concise. 3.55. What is the difference between the highest and the lowest Tax (as % of total tax revenue) in Germany?
Your response must be concise. 2.22. What is the difference between the highest and the lowest Tax (as % of total tax revenue) of Ghana?
Keep it short and to the point. 6.02. What is the difference between the highest and the lowest Tax (as % of total tax revenue) of Nepal?
Keep it short and to the point. 5.96. 